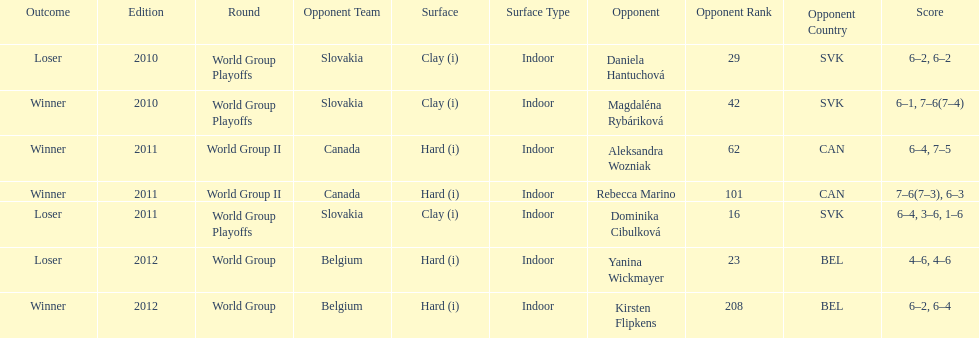Number of games in the match against dominika cibulkova? 3. 